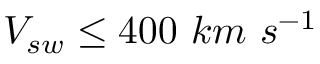<formula> <loc_0><loc_0><loc_500><loc_500>V _ { s w } \leq 4 0 0 k m s ^ { - 1 }</formula> 